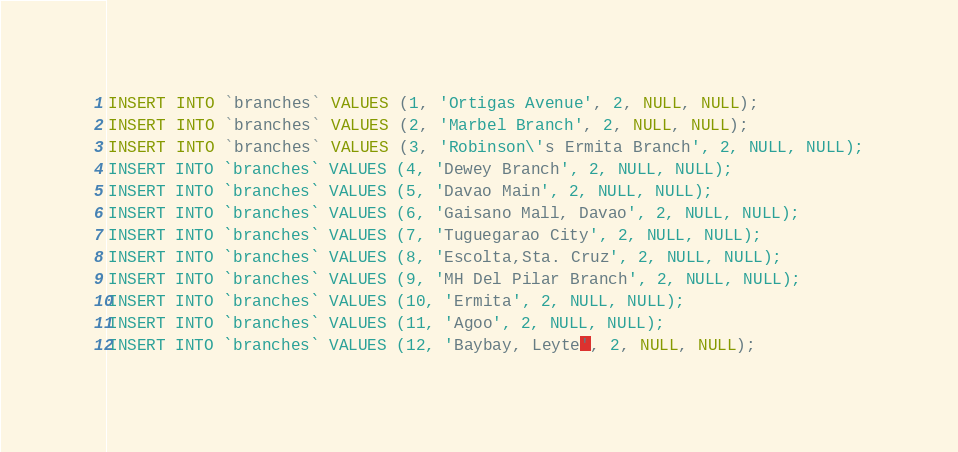<code> <loc_0><loc_0><loc_500><loc_500><_SQL_>
INSERT INTO `branches` VALUES (1, 'Ortigas Avenue', 2, NULL, NULL);
INSERT INTO `branches` VALUES (2, 'Marbel Branch', 2, NULL, NULL);
INSERT INTO `branches` VALUES (3, 'Robinson\'s Ermita Branch', 2, NULL, NULL);
INSERT INTO `branches` VALUES (4, 'Dewey Branch', 2, NULL, NULL);
INSERT INTO `branches` VALUES (5, 'Davao Main', 2, NULL, NULL);
INSERT INTO `branches` VALUES (6, 'Gaisano Mall, Davao', 2, NULL, NULL);
INSERT INTO `branches` VALUES (7, 'Tuguegarao City', 2, NULL, NULL);
INSERT INTO `branches` VALUES (8, 'Escolta,Sta. Cruz', 2, NULL, NULL);
INSERT INTO `branches` VALUES (9, 'MH Del Pilar Branch', 2, NULL, NULL);
INSERT INTO `branches` VALUES (10, 'Ermita', 2, NULL, NULL);
INSERT INTO `branches` VALUES (11, 'Agoo', 2, NULL, NULL);
INSERT INTO `branches` VALUES (12, 'Baybay, Leyte', 2, NULL, NULL);</code> 